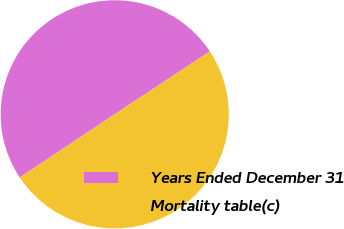<chart> <loc_0><loc_0><loc_500><loc_500><pie_chart><fcel>Years Ended December 31<fcel>Mortality table(c)<nl><fcel>50.06%<fcel>49.94%<nl></chart> 